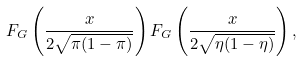Convert formula to latex. <formula><loc_0><loc_0><loc_500><loc_500>F _ { G } \left ( \frac { x } { 2 \sqrt { \pi ( 1 - \pi ) } } \right ) F _ { G } \left ( \frac { x } { 2 \sqrt { \eta ( 1 - \eta ) } } \right ) ,</formula> 